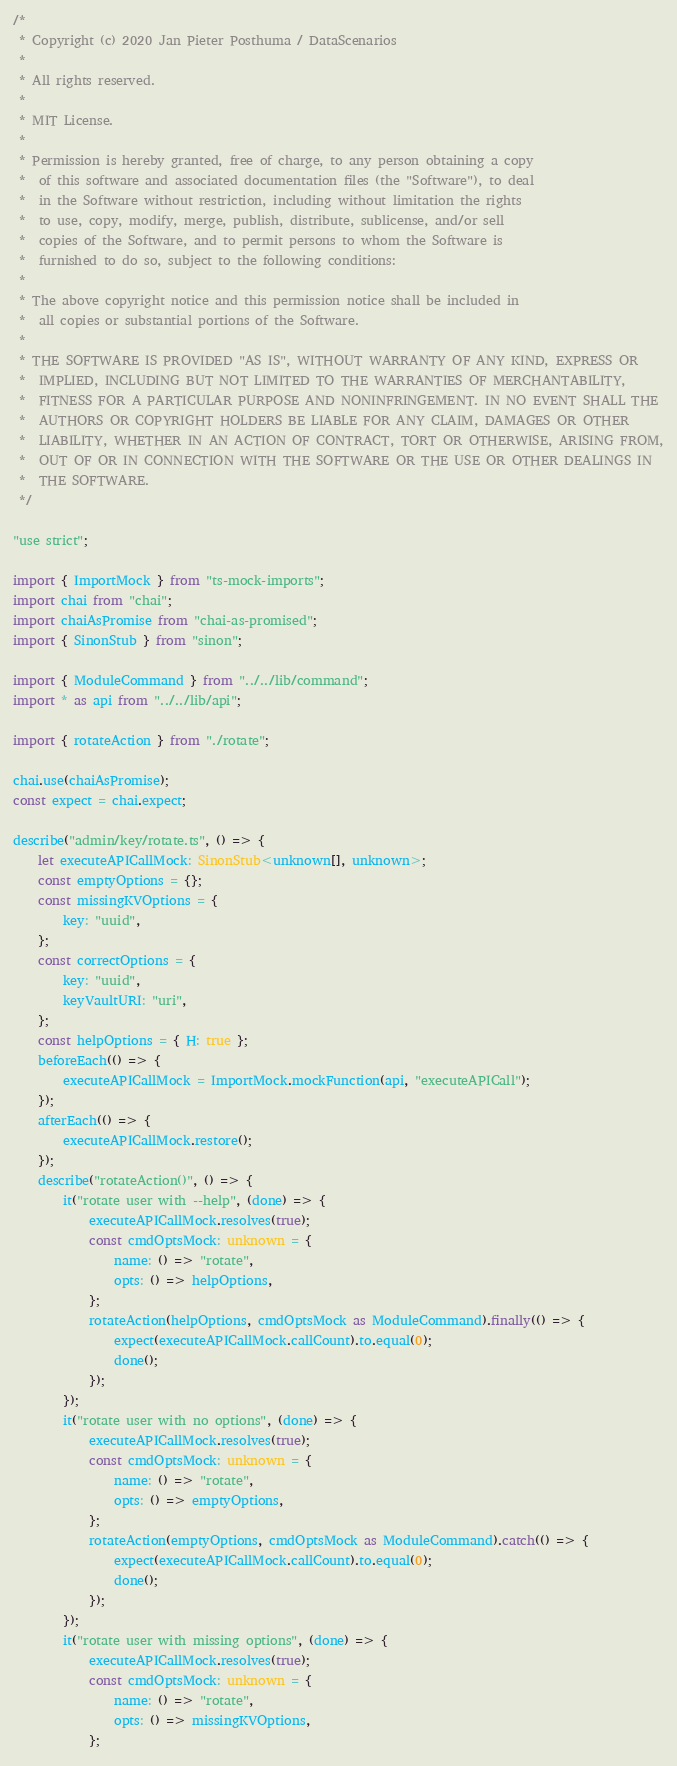<code> <loc_0><loc_0><loc_500><loc_500><_TypeScript_>/*
 * Copyright (c) 2020 Jan Pieter Posthuma / DataScenarios
 *
 * All rights reserved.
 *
 * MIT License.
 *
 * Permission is hereby granted, free of charge, to any person obtaining a copy
 *  of this software and associated documentation files (the "Software"), to deal
 *  in the Software without restriction, including without limitation the rights
 *  to use, copy, modify, merge, publish, distribute, sublicense, and/or sell
 *  copies of the Software, and to permit persons to whom the Software is
 *  furnished to do so, subject to the following conditions:
 *
 * The above copyright notice and this permission notice shall be included in
 *  all copies or substantial portions of the Software.
 *
 * THE SOFTWARE IS PROVIDED "AS IS", WITHOUT WARRANTY OF ANY KIND, EXPRESS OR
 *  IMPLIED, INCLUDING BUT NOT LIMITED TO THE WARRANTIES OF MERCHANTABILITY,
 *  FITNESS FOR A PARTICULAR PURPOSE AND NONINFRINGEMENT. IN NO EVENT SHALL THE
 *  AUTHORS OR COPYRIGHT HOLDERS BE LIABLE FOR ANY CLAIM, DAMAGES OR OTHER
 *  LIABILITY, WHETHER IN AN ACTION OF CONTRACT, TORT OR OTHERWISE, ARISING FROM,
 *  OUT OF OR IN CONNECTION WITH THE SOFTWARE OR THE USE OR OTHER DEALINGS IN
 *  THE SOFTWARE.
 */

"use strict";

import { ImportMock } from "ts-mock-imports";
import chai from "chai";
import chaiAsPromise from "chai-as-promised";
import { SinonStub } from "sinon";

import { ModuleCommand } from "../../lib/command";
import * as api from "../../lib/api";

import { rotateAction } from "./rotate";

chai.use(chaiAsPromise);
const expect = chai.expect;

describe("admin/key/rotate.ts", () => {
    let executeAPICallMock: SinonStub<unknown[], unknown>;
    const emptyOptions = {};
    const missingKVOptions = {
        key: "uuid",
    };
    const correctOptions = {
        key: "uuid",
        keyVaultURI: "uri",
    };
    const helpOptions = { H: true };
    beforeEach(() => {
        executeAPICallMock = ImportMock.mockFunction(api, "executeAPICall");
    });
    afterEach(() => {
        executeAPICallMock.restore();
    });
    describe("rotateAction()", () => {
        it("rotate user with --help", (done) => {
            executeAPICallMock.resolves(true);
            const cmdOptsMock: unknown = {
                name: () => "rotate",
                opts: () => helpOptions,
            };
            rotateAction(helpOptions, cmdOptsMock as ModuleCommand).finally(() => {
                expect(executeAPICallMock.callCount).to.equal(0);
                done();
            });
        });
        it("rotate user with no options", (done) => {
            executeAPICallMock.resolves(true);
            const cmdOptsMock: unknown = {
                name: () => "rotate",
                opts: () => emptyOptions,
            };
            rotateAction(emptyOptions, cmdOptsMock as ModuleCommand).catch(() => {
                expect(executeAPICallMock.callCount).to.equal(0);
                done();
            });
        });
        it("rotate user with missing options", (done) => {
            executeAPICallMock.resolves(true);
            const cmdOptsMock: unknown = {
                name: () => "rotate",
                opts: () => missingKVOptions,
            };</code> 